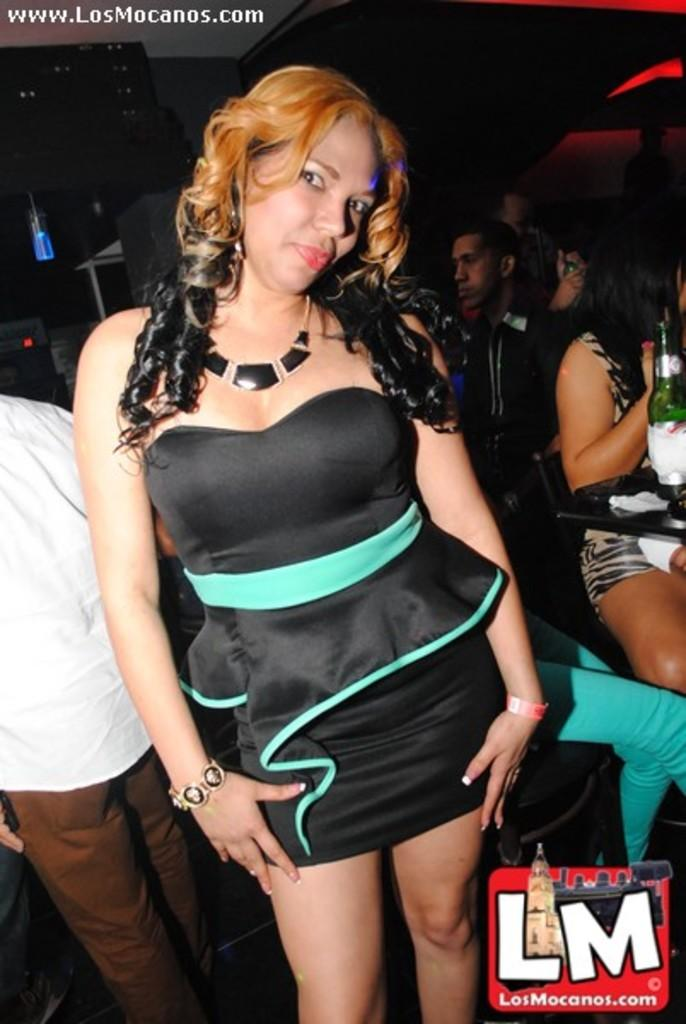<image>
Create a compact narrative representing the image presented. A woman posing for the camera for LosMocanos.com 